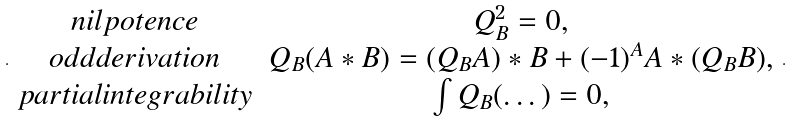<formula> <loc_0><loc_0><loc_500><loc_500>. \begin{array} { c c } n i l p o t e n c e & Q _ { B } ^ { 2 } = 0 , \\ o d d d e r i v a t i o n & Q _ { B } ( A * B ) = ( Q _ { B } A ) * B + ( - 1 ) ^ { A } A * ( Q _ { B } B ) , \\ p a r t i a l i n t e g r a b i l i t y & \int Q _ { B } ( \dots ) = 0 , \end{array} .</formula> 